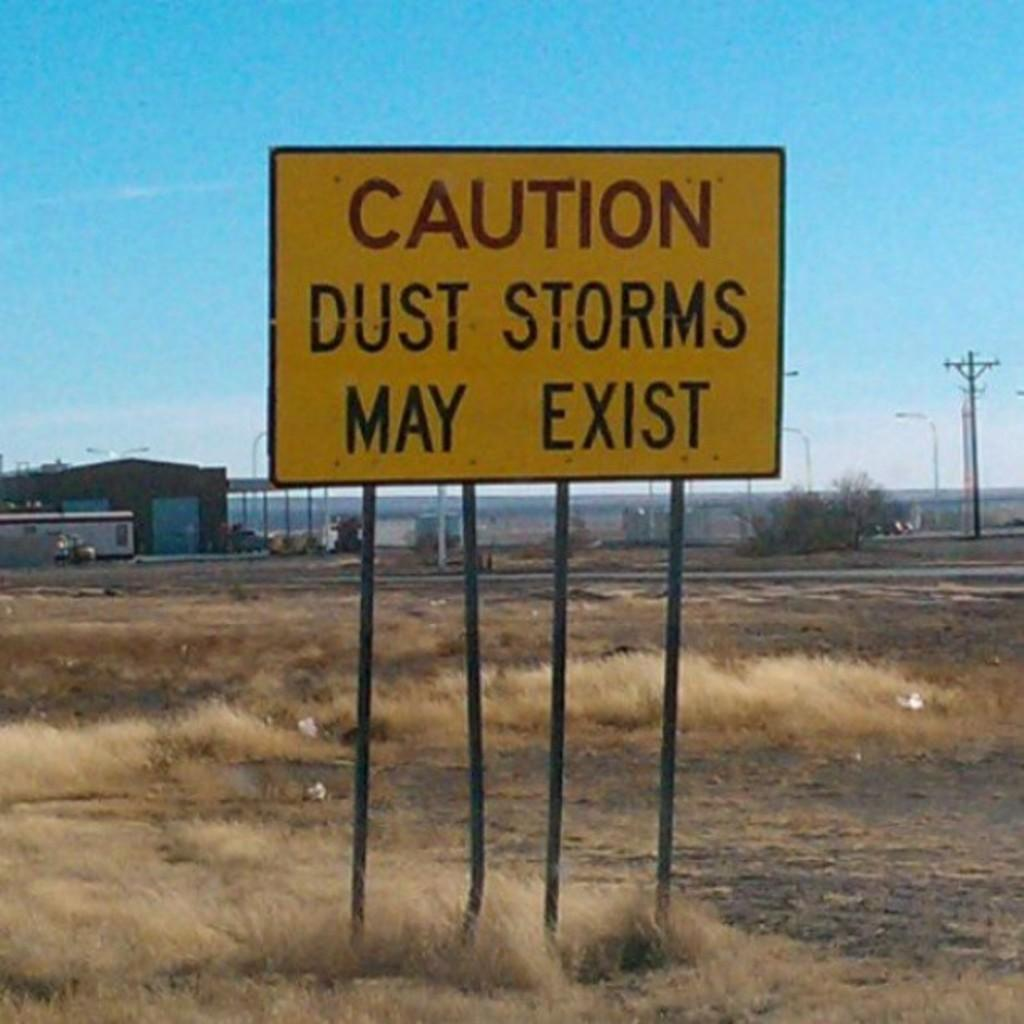<image>
Relay a brief, clear account of the picture shown. A yellow sign in a field that says that dust storms may exist. 